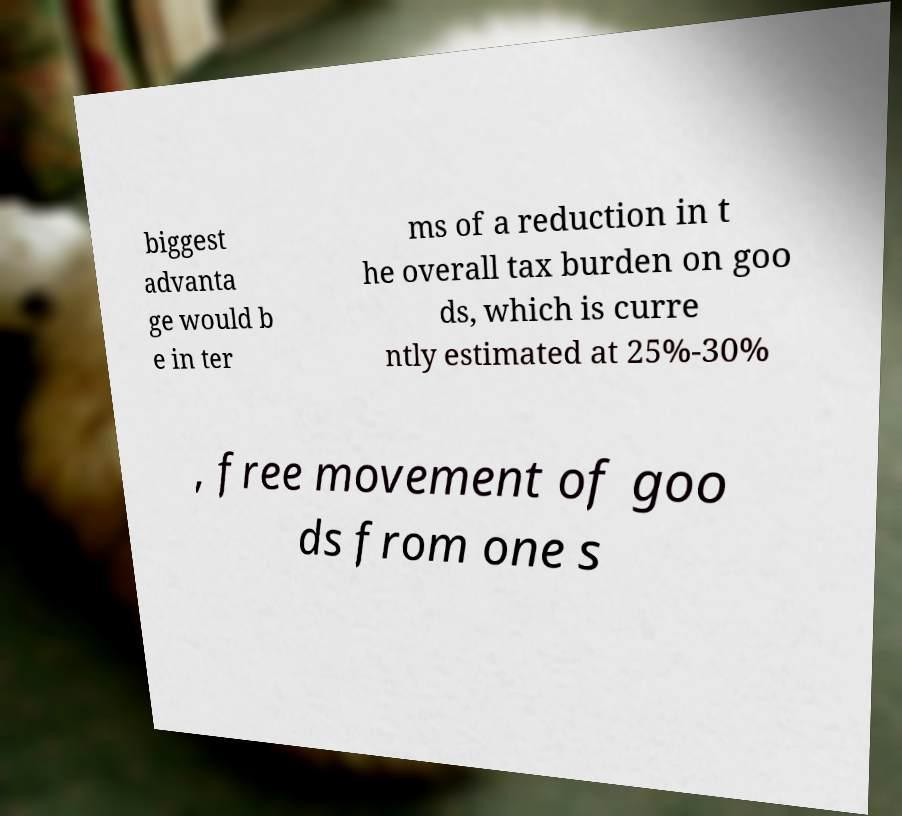Can you read and provide the text displayed in the image?This photo seems to have some interesting text. Can you extract and type it out for me? biggest advanta ge would b e in ter ms of a reduction in t he overall tax burden on goo ds, which is curre ntly estimated at 25%-30% , free movement of goo ds from one s 